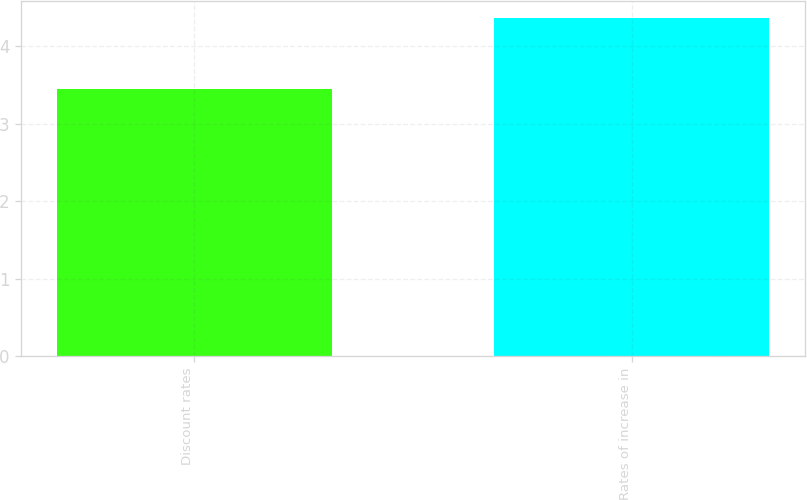Convert chart. <chart><loc_0><loc_0><loc_500><loc_500><bar_chart><fcel>Discount rates<fcel>Rates of increase in<nl><fcel>3.45<fcel>4.36<nl></chart> 